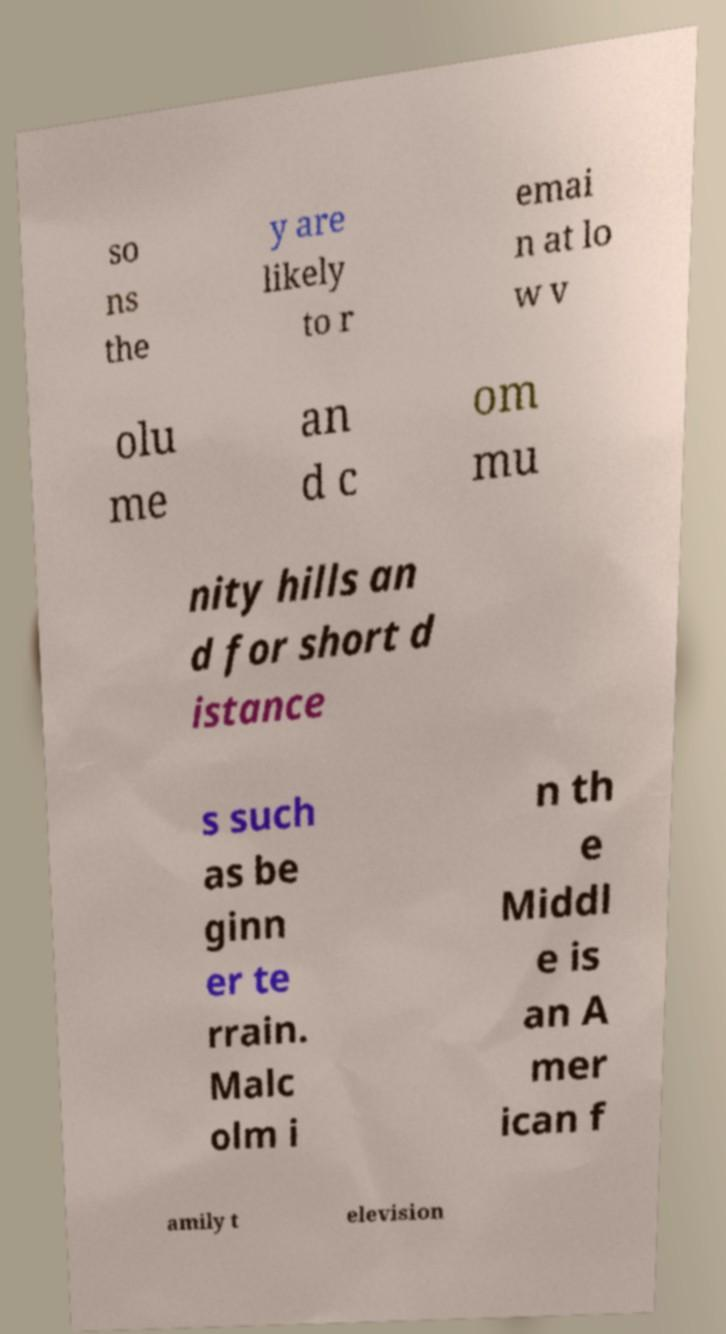Can you accurately transcribe the text from the provided image for me? so ns the y are likely to r emai n at lo w v olu me an d c om mu nity hills an d for short d istance s such as be ginn er te rrain. Malc olm i n th e Middl e is an A mer ican f amily t elevision 